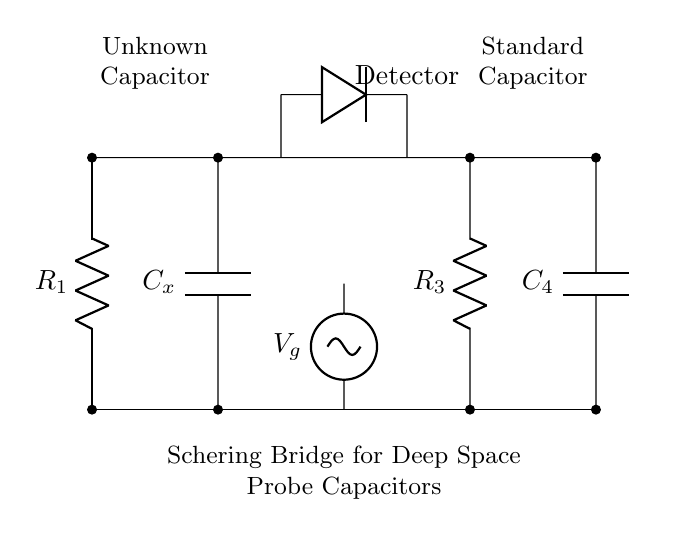What is the type of this circuit? The circuit is a Schering bridge, which is specifically used to measure unknown capacitor values by balancing against known values. This is indicated by the arrangement of resistors and capacitors along with a voltage source and detector.
Answer: Schering bridge What component is labeled as C_x? C_x is the unknown capacitor that is being characterized in the Schering bridge setup, and it is placed in the left branch of the bridge.
Answer: Unknown capacitor What is the role of the voltage source in this circuit? The voltage source, labeled V_g, provides the necessary electric potential that drives the current through the bridge, allowing measurements of the unknown capacitor based on the bridge's balance conditions.
Answer: Provides voltage How many resistors are present in the circuit? There are two resistors, R_1 and R_3, positioned in the circuit to establish a ratio that balances the bridge against the capacitor values.
Answer: Two What happens at the detector in this circuit? The detector indicates whether the bridge is balanced or unbalanced based on the voltages from the two branches; it typically displays zero voltage when balanced, indicating that the unknown capacitor value matches the known conditions.
Answer: Shows balance What is the purpose of the Schering bridge in deep space probes? The Schering bridge is employed to accurately measure capacitor values that may be used in the designed circuits of deep space probes, ensuring reliability in electronic components crucial for communication and navigation in space.
Answer: Measure capacitors How does the arrangement of components affect the measurement? The specific arrangement allows for the comparison of the unknown capacitor with a standard capacitor and the chosen resistors, determining the capacitance based on bridge balancing principles. Balancing conditions are critical for accurate measurement.
Answer: Enables accurate measurement 